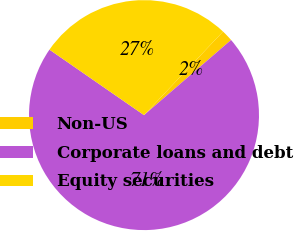<chart> <loc_0><loc_0><loc_500><loc_500><pie_chart><fcel>Non-US<fcel>Corporate loans and debt<fcel>Equity securities<nl><fcel>1.61%<fcel>70.97%<fcel>27.42%<nl></chart> 